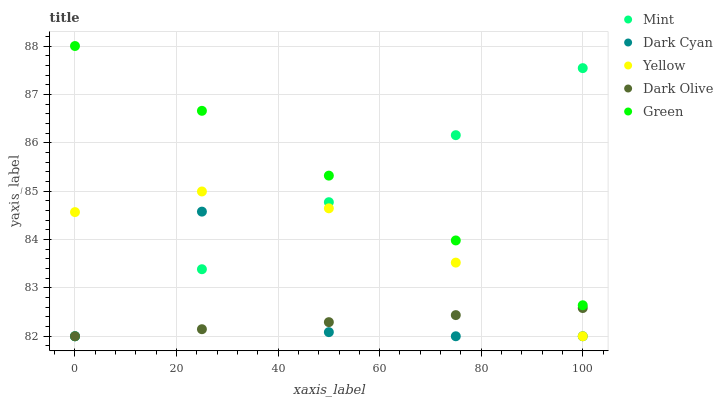Does Dark Olive have the minimum area under the curve?
Answer yes or no. Yes. Does Green have the maximum area under the curve?
Answer yes or no. Yes. Does Green have the minimum area under the curve?
Answer yes or no. No. Does Dark Olive have the maximum area under the curve?
Answer yes or no. No. Is Mint the smoothest?
Answer yes or no. Yes. Is Dark Cyan the roughest?
Answer yes or no. Yes. Is Green the smoothest?
Answer yes or no. No. Is Green the roughest?
Answer yes or no. No. Does Dark Cyan have the lowest value?
Answer yes or no. Yes. Does Green have the lowest value?
Answer yes or no. No. Does Green have the highest value?
Answer yes or no. Yes. Does Dark Olive have the highest value?
Answer yes or no. No. Is Yellow less than Green?
Answer yes or no. Yes. Is Green greater than Yellow?
Answer yes or no. Yes. Does Yellow intersect Mint?
Answer yes or no. Yes. Is Yellow less than Mint?
Answer yes or no. No. Is Yellow greater than Mint?
Answer yes or no. No. Does Yellow intersect Green?
Answer yes or no. No. 